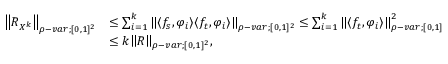<formula> <loc_0><loc_0><loc_500><loc_500>\begin{array} { r l } { { \left \| { R _ { X ^ { k } } } \right \| } _ { \rho - v a r ; [ 0 , 1 ] ^ { 2 } } } & { \leq \sum _ { i = 1 } ^ { k } { \left \| { \langle f _ { s } , \varphi _ { i } \rangle \langle f _ { t } , \varphi _ { i } \rangle } \right \| } _ { \rho - v a r ; [ 0 , 1 ] ^ { 2 } } \leq \sum _ { i = 1 } ^ { k } { \left \| { \langle f _ { t } , \varphi _ { i } \rangle } \right \| } _ { \rho - v a r ; [ 0 , 1 ] } ^ { 2 } } \\ & { \leq k { \left \| { R } \right \| } _ { \rho - v a r ; [ 0 , 1 ] ^ { 2 } } , } \end{array}</formula> 